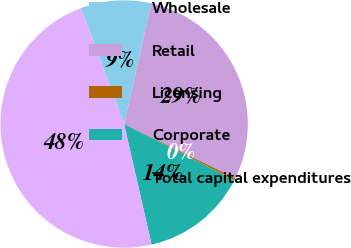Convert chart. <chart><loc_0><loc_0><loc_500><loc_500><pie_chart><fcel>Wholesale<fcel>Retail<fcel>Licensing<fcel>Corporate<fcel>Total capital expenditures<nl><fcel>9.19%<fcel>28.68%<fcel>0.28%<fcel>13.95%<fcel>47.89%<nl></chart> 